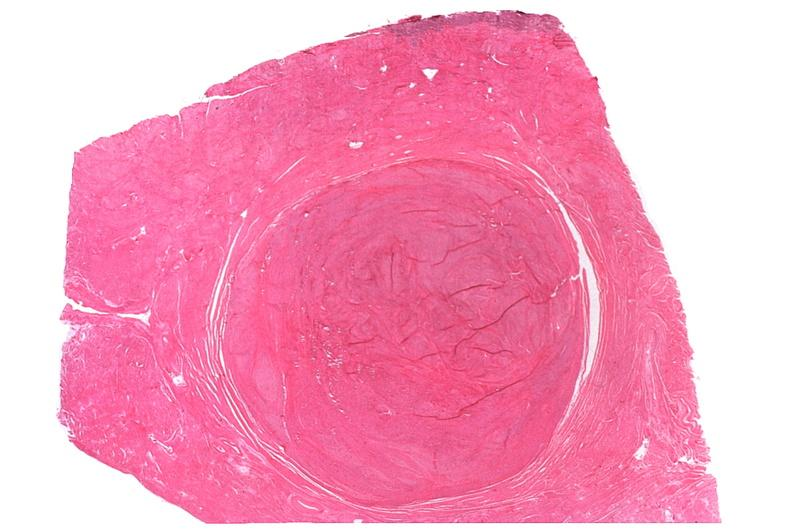s female reproductive present?
Answer the question using a single word or phrase. Yes 